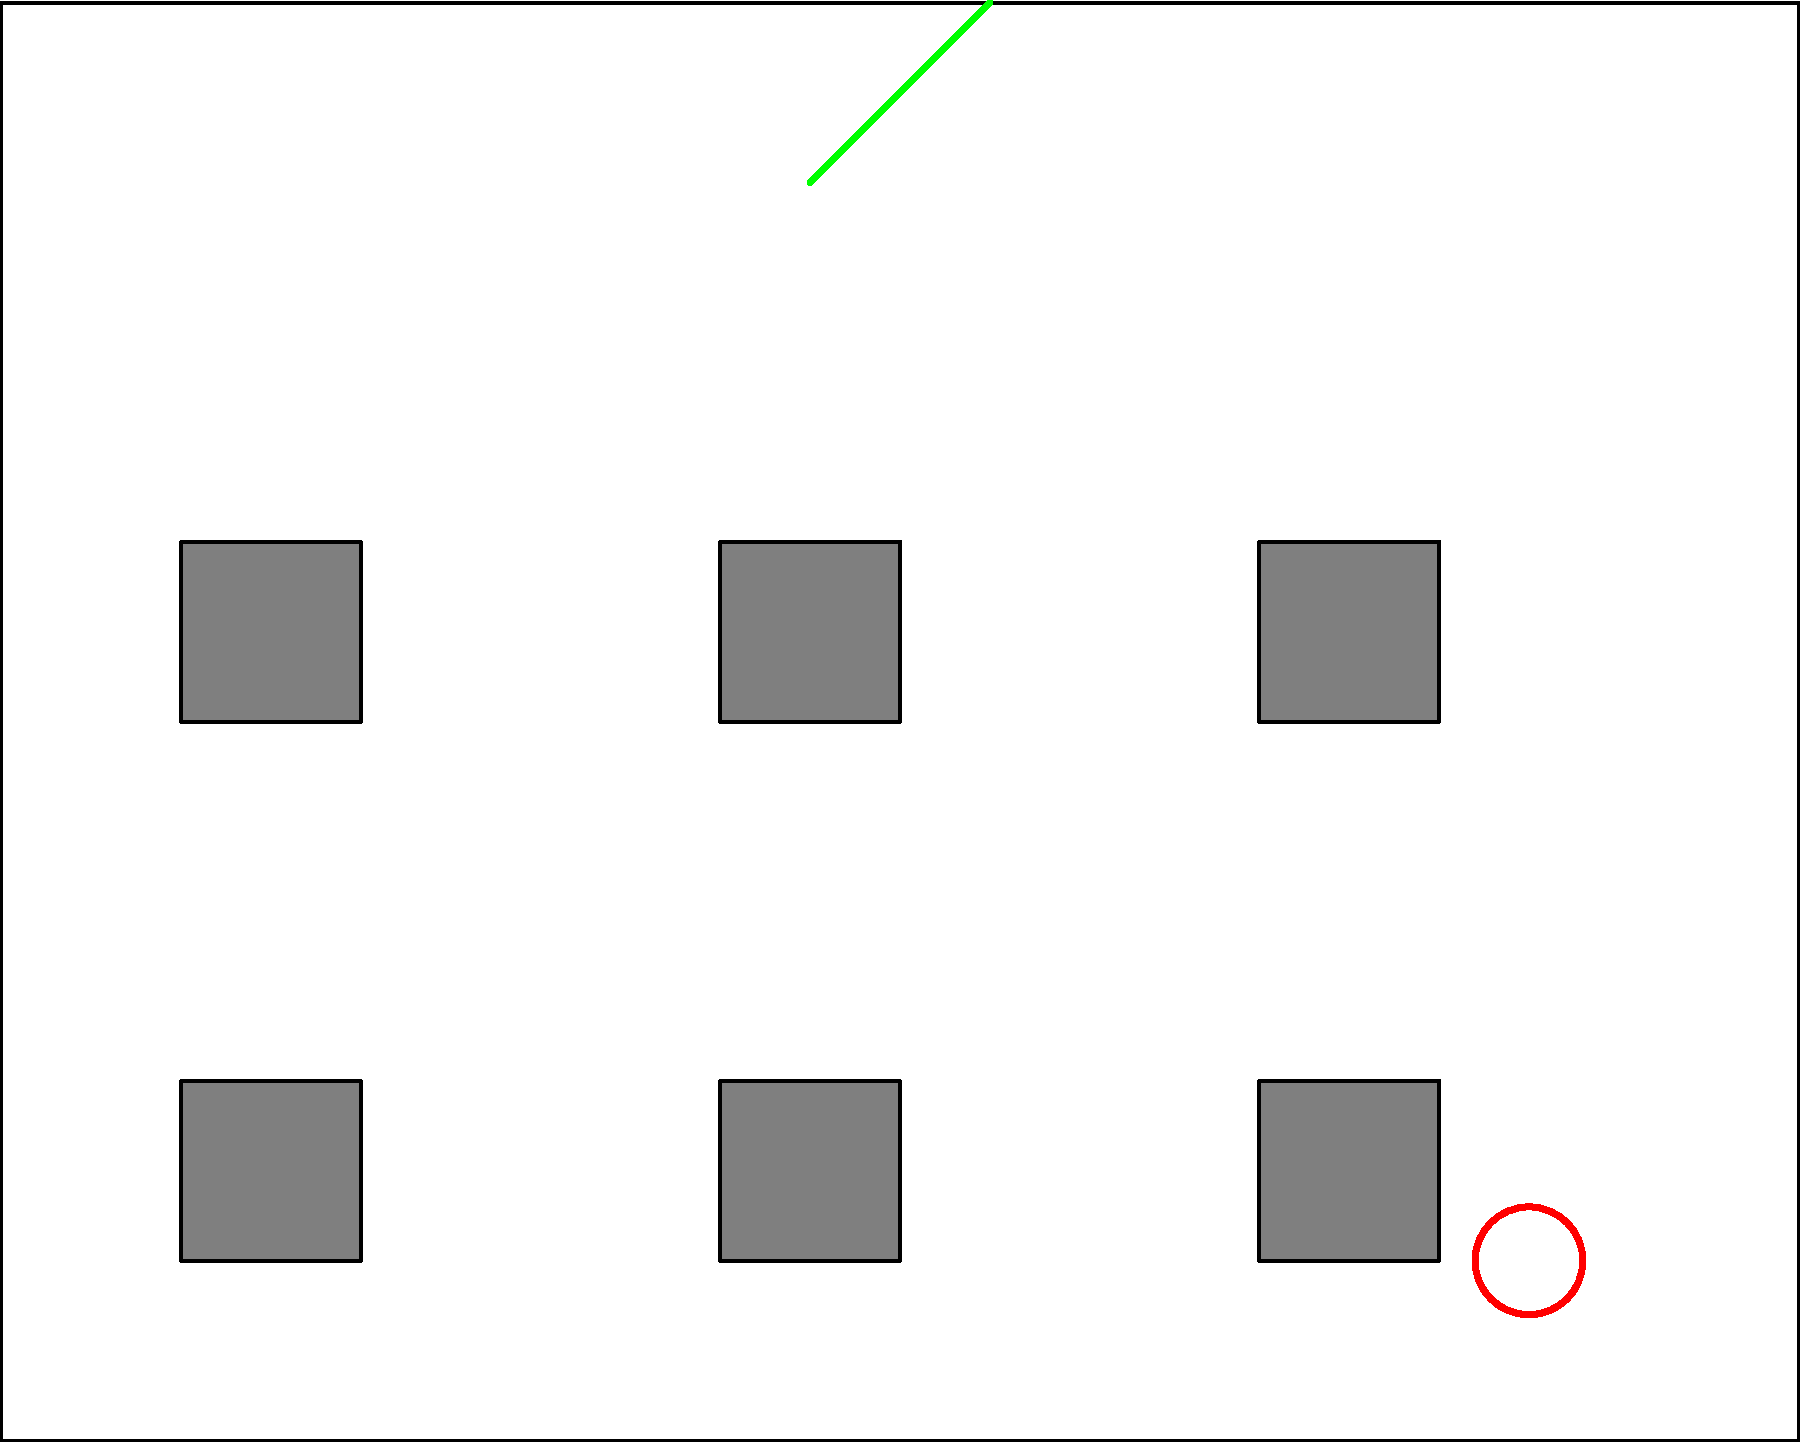In the given workplace floor plan, identify the number of potential safety hazards present. What steps should be taken to address these hazards? To identify and address the safety hazards in this workplace floor plan, follow these steps:

1. Scan the entire floor plan systematically.

2. Identify visible hazards:
   a. Red circle: Represents a spill (located at the bottom right)
   b. Green line: Indicates an exposed wire (top center)
   c. Yellow triangle: Shows a caution sign (center right)

3. Count the number of hazards: There are 3 visible hazards.

4. Steps to address these hazards:
   a. Spill:
      - Immediately cordon off the area
      - Clean up the spill using appropriate materials
      - Place a "Wet Floor" sign until the area is completely dry
   
   b. Exposed wire:
      - Turn off power to the affected area
      - Call a qualified electrician to properly secure and insulate the wire
      - Ensure the area is safe before resuming work
   
   c. Caution sign:
      - Investigate the reason for the caution sign
      - Address the underlying issue (e.g., uneven floor, ongoing maintenance)
      - Remove the sign only when the hazard has been fully resolved

5. General safety measures:
   - Conduct regular safety inspections
   - Provide proper training to employees on hazard identification and reporting
   - Maintain clear walkways and emergency exits
   - Ensure proper lighting throughout the workspace
Answer: 3 hazards; Clean spill, fix exposed wire, address caution area 